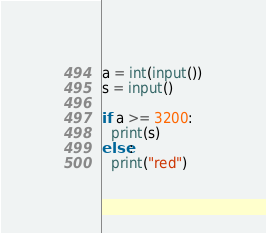<code> <loc_0><loc_0><loc_500><loc_500><_Python_>a = int(input())
s = input()

if a >= 3200:
  print(s)
else:
  print("red")</code> 